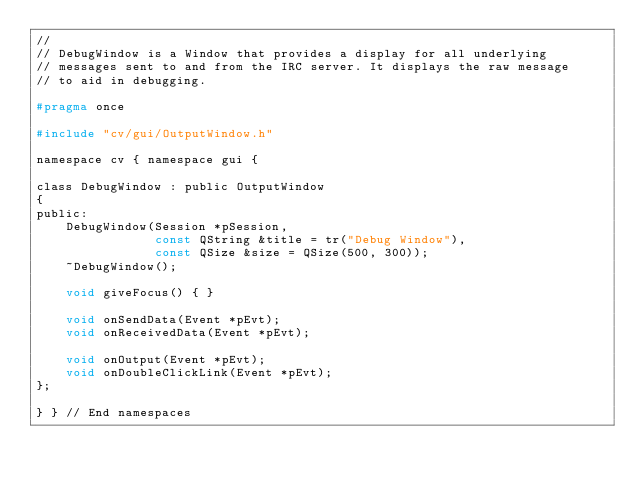Convert code to text. <code><loc_0><loc_0><loc_500><loc_500><_C_>//
// DebugWindow is a Window that provides a display for all underlying
// messages sent to and from the IRC server. It displays the raw message
// to aid in debugging.

#pragma once

#include "cv/gui/OutputWindow.h"

namespace cv { namespace gui {

class DebugWindow : public OutputWindow
{
public:
    DebugWindow(Session *pSession,
                const QString &title = tr("Debug Window"),
                const QSize &size = QSize(500, 300));
    ~DebugWindow();

    void giveFocus() { }

    void onSendData(Event *pEvt);
    void onReceivedData(Event *pEvt);

    void onOutput(Event *pEvt);
    void onDoubleClickLink(Event *pEvt);
};

} } // End namespaces
</code> 